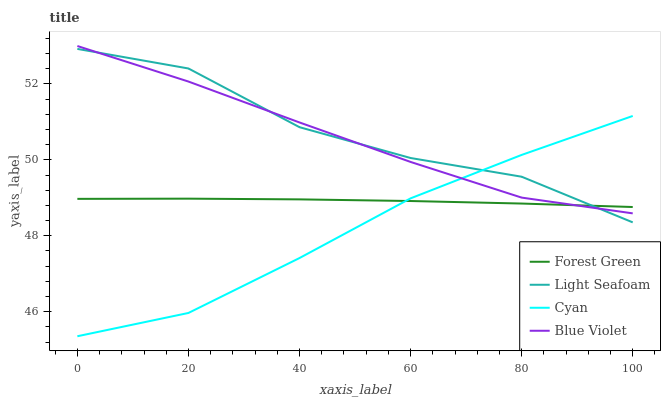Does Cyan have the minimum area under the curve?
Answer yes or no. Yes. Does Light Seafoam have the maximum area under the curve?
Answer yes or no. Yes. Does Forest Green have the minimum area under the curve?
Answer yes or no. No. Does Forest Green have the maximum area under the curve?
Answer yes or no. No. Is Forest Green the smoothest?
Answer yes or no. Yes. Is Light Seafoam the roughest?
Answer yes or no. Yes. Is Light Seafoam the smoothest?
Answer yes or no. No. Is Forest Green the roughest?
Answer yes or no. No. Does Cyan have the lowest value?
Answer yes or no. Yes. Does Light Seafoam have the lowest value?
Answer yes or no. No. Does Blue Violet have the highest value?
Answer yes or no. Yes. Does Light Seafoam have the highest value?
Answer yes or no. No. Does Blue Violet intersect Light Seafoam?
Answer yes or no. Yes. Is Blue Violet less than Light Seafoam?
Answer yes or no. No. Is Blue Violet greater than Light Seafoam?
Answer yes or no. No. 